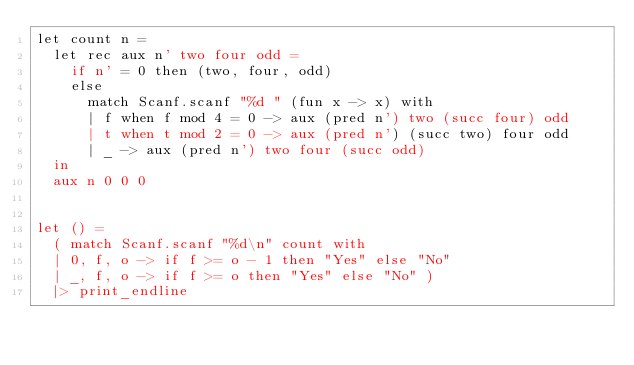<code> <loc_0><loc_0><loc_500><loc_500><_OCaml_>let count n =
  let rec aux n' two four odd =
    if n' = 0 then (two, four, odd)
    else
      match Scanf.scanf "%d " (fun x -> x) with
      | f when f mod 4 = 0 -> aux (pred n') two (succ four) odd
      | t when t mod 2 = 0 -> aux (pred n') (succ two) four odd
      | _ -> aux (pred n') two four (succ odd)
  in
  aux n 0 0 0


let () =
  ( match Scanf.scanf "%d\n" count with
  | 0, f, o -> if f >= o - 1 then "Yes" else "No"
  | _, f, o -> if f >= o then "Yes" else "No" )
  |> print_endline</code> 